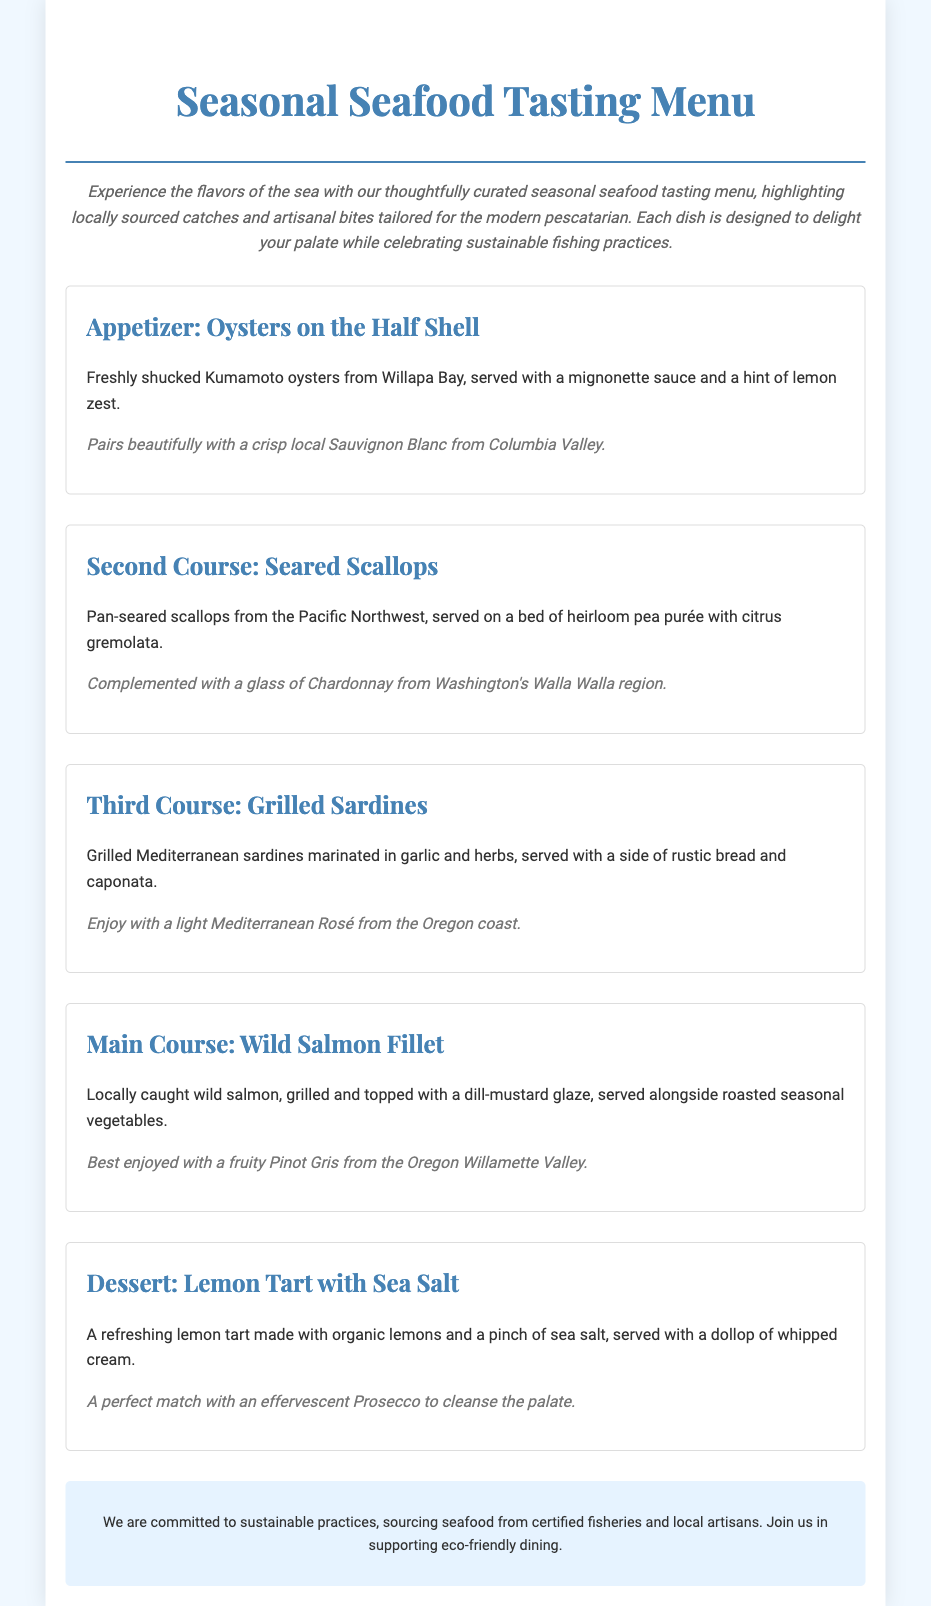What is the title of the menu? The title of the menu is prominently displayed at the top of the document, indicating the theme of the offerings.
Answer: Seasonal Seafood Tasting Menu What is the first appetizer listed? The appetizer section provides the first dish served in the tasting menu, which is noted clearly in the document.
Answer: Oysters on the Half Shell What local region are the Kumamoto oysters sourced from? The document specifies the origin of the oysters, which is essential information for seafood sourcing.
Answer: Willapa Bay What is the second course of the menu? The second course is clearly outlined in the menu as part of the tasting experience, following the appetizer.
Answer: Seared Scallops Which wine pairs with the Grilled Sardines? Each dish includes a recommended pairing, noted in the respective course section of the document.
Answer: Light Mediterranean Rosé How is the Wild Salmon Fillet prepared? The description of the main course includes specific preparation details about the salmon, which is relevant for diners.
Answer: Grilled and topped with a dill-mustard glaze What dessert is offered at the end of the menu? The menu concludes with a delightful dessert section, clearly articulating the final course in the tasting experience.
Answer: Lemon Tart with Sea Salt What is the significance of the sustainability note? The document includes a section dedicated to sustainability, emphasizing the importance of sourcing practices.
Answer: Commitment to sustainable practices What type of cuisine does the menu highlight? The overall theme of the menu and the types of dishes offered are indicative of the cuisine being celebrated in the experience.
Answer: Seafood 